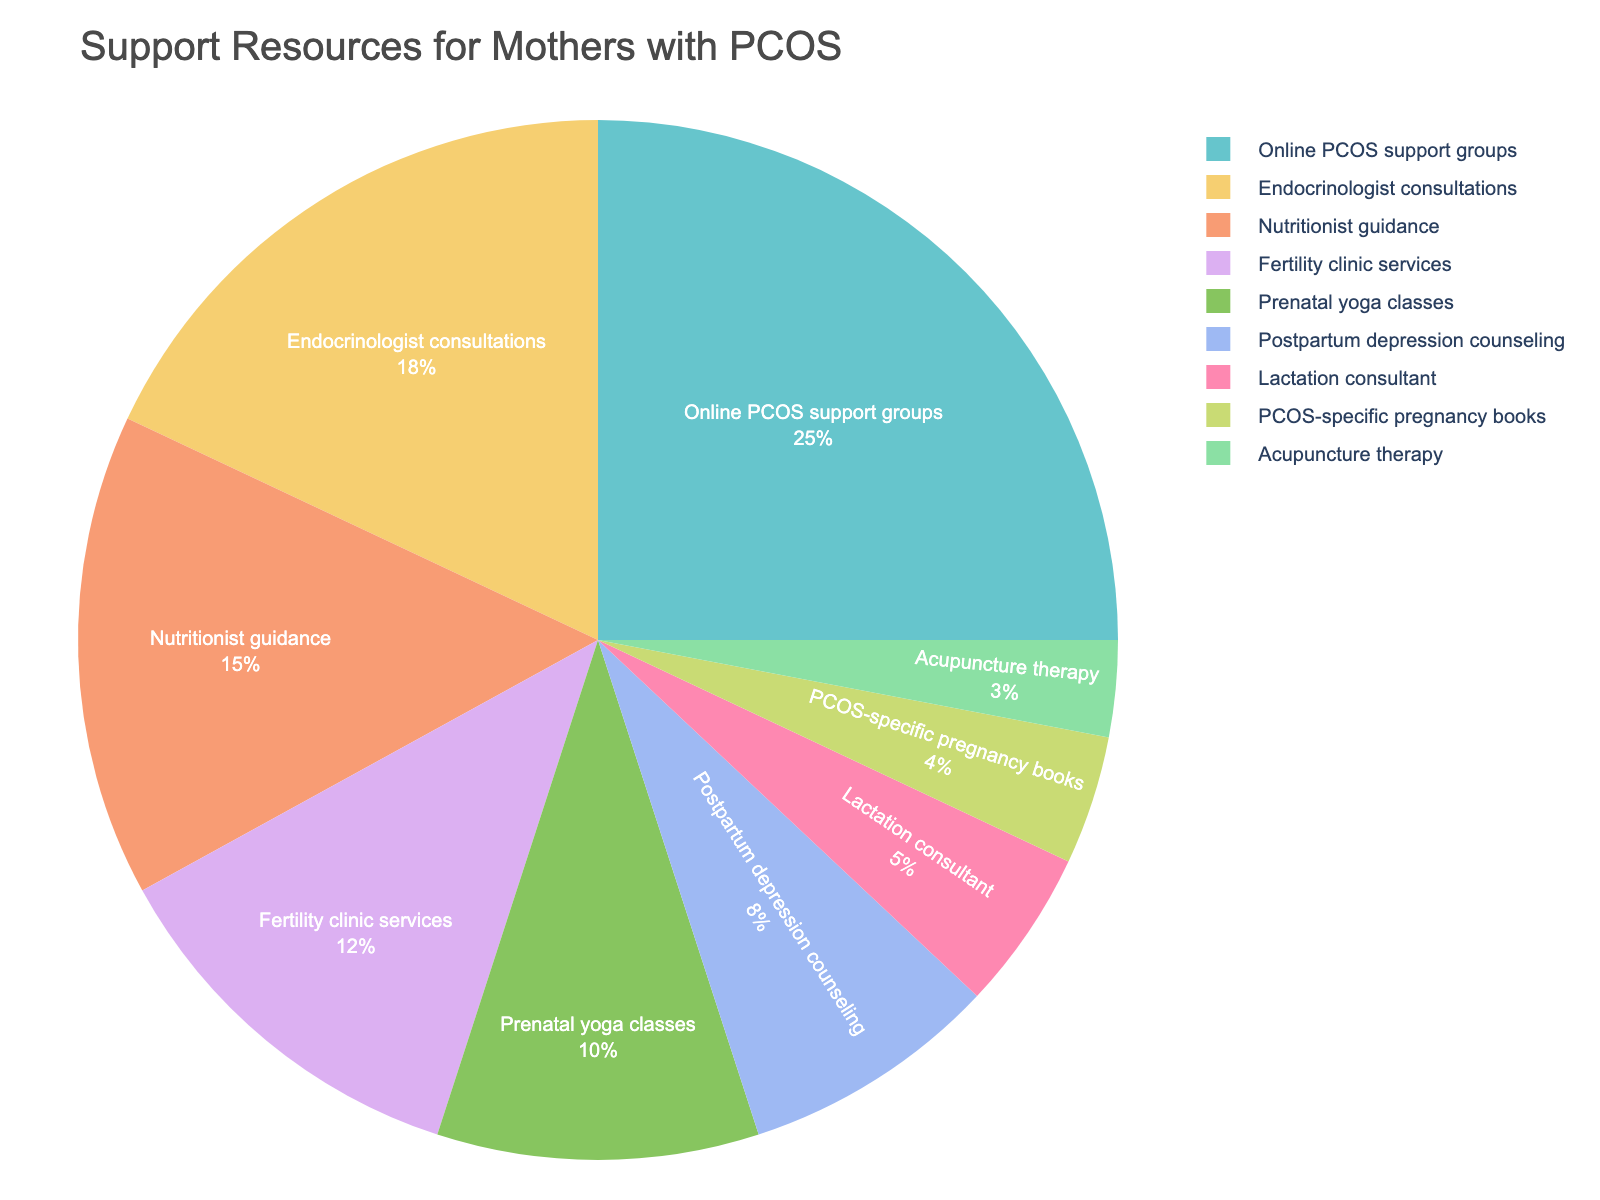Which resource has been utilized the most by mothers with PCOS during pregnancy and postpartum? The pie chart shows the distribution of various support resources used by mothers with PCOS. The resource with the highest percentage is represented by the largest section of the pie chart. By looking at the chart, "Online PCOS support groups" has the largest portion, indicating it is the most utilized resource.
Answer: Online PCOS support groups Which resource has the smallest percentage of utilization? By observing the pie chart, the smallest section represents the resource used the least. "Acupuncture therapy" has the smallest percentage, indicating it is the least utilized.
Answer: Acupuncture therapy How much more popular are Online PCOS support groups compared to Prenatal yoga classes? To find this, subtract the percentage of usage of Prenatal yoga classes from Online PCOS support groups. From the chart, Online PCOS support groups have 25% and Prenatal yoga classes have 10%. The difference is 25% - 10% = 15%.
Answer: 15% What is the combined usage percentage of Endocrinologist consultations and Nutritionist guidance? To find the combined usage, add the percentage of Endocrinologist consultations and Nutritionist guidance. From the chart, Endocrinologist consultations have 18% and Nutritionist guidance has 15%. The combined usage is 18% + 15% = 33%.
Answer: 33% Are Fertility clinic services used more or less than Nutritionist guidance? By what percentage? Compare the percentages of Fertility clinic services and Nutritionist guidance from the chart. Fertility clinic services have 12%, and Nutritionist guidance has 15%. Subtract the smaller percentage from the larger one: 15% - 12% = 3%. Nutritionist guidance is used 3% more than Fertility clinic services.
Answer: 3% more What is the average utilization percentage of the top three resources? To find the average, add the percentages of the top three resources and divide by three. The top three are Online PCOS support groups (25%), Endocrinologist consultations (18%), and Nutritionist guidance (15%). The sum is 25% + 18% + 15% = 58%. The average is 58% / 3 = 19.33%.
Answer: 19.33% How do the usage percentages of Lactation consultant and Postpartum depression counseling compare? From the chart, Lactation consultant has 5% and Postpartum depression counseling has 8%. Subtract the smaller percentage from the larger one to find the difference: 8% - 5% = 3%. Postpartum depression counseling is used 3% more than Lactation consultant.
Answer: 3% more How does the utilization of Prenatal yoga classes compare to the cumulative percentage of PCOS-specific pregnancy books and Acupuncture therapy? Add the percentages of PCOS-specific pregnancy books and Acupuncture therapy: 4% + 3% = 7%. Compare it with Prenatal yoga classes, which have 10%. Prenatal yoga classes have a higher usage by 10% - 7% = 3%.
Answer: 3% more What percentage of mothers utilized either Endocrinologist consultations or Fertility clinic services? Add the percentages of Endocrinologist consultations and Fertility clinic services. Endocrinologist consultations have 18% and Fertility clinic services have 12%. The combined percentage is 18% + 12% = 30%.
Answer: 30% 